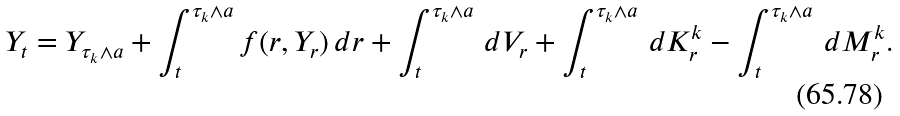Convert formula to latex. <formula><loc_0><loc_0><loc_500><loc_500>Y _ { t } = Y _ { \tau _ { k } \wedge a } + \int ^ { \tau _ { k } \wedge a } _ { t } f ( r , Y _ { r } ) \, d r + \int ^ { \tau _ { k } \wedge a } _ { t } \, d V _ { r } + \int ^ { \tau _ { k } \wedge a } _ { t } \, d K ^ { k } _ { r } - \int ^ { \tau _ { k } \wedge a } _ { t } \, d M ^ { k } _ { r } .</formula> 